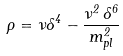<formula> <loc_0><loc_0><loc_500><loc_500>\rho = \nu \Lambda ^ { 4 } - \frac { \nu ^ { 2 } \, \Lambda ^ { 6 } } { m ^ { 2 } _ { p l } }</formula> 